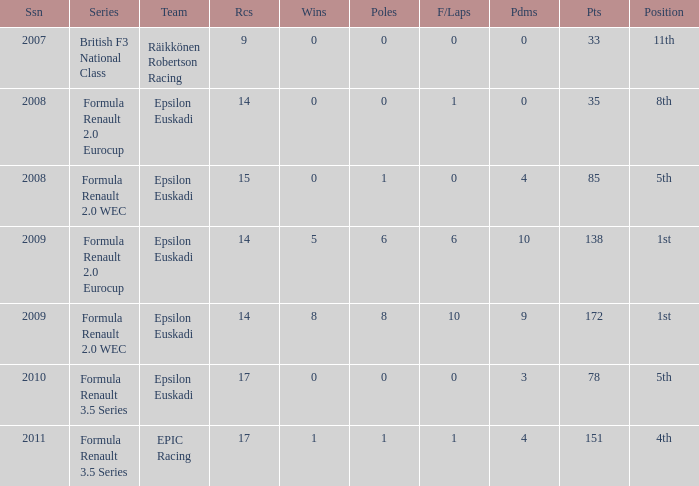How many f/laps when he finished 8th? 1.0. 